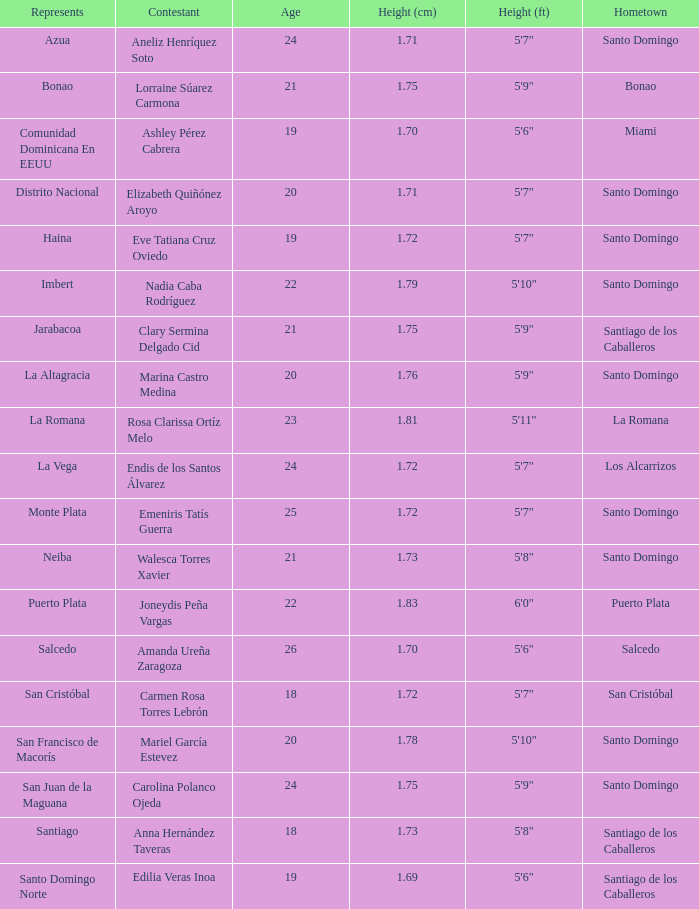Identify the oldest era 26.0. 